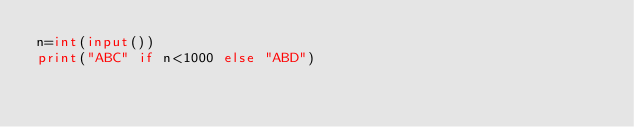<code> <loc_0><loc_0><loc_500><loc_500><_Python_>n=int(input())
print("ABC" if n<1000 else "ABD")</code> 